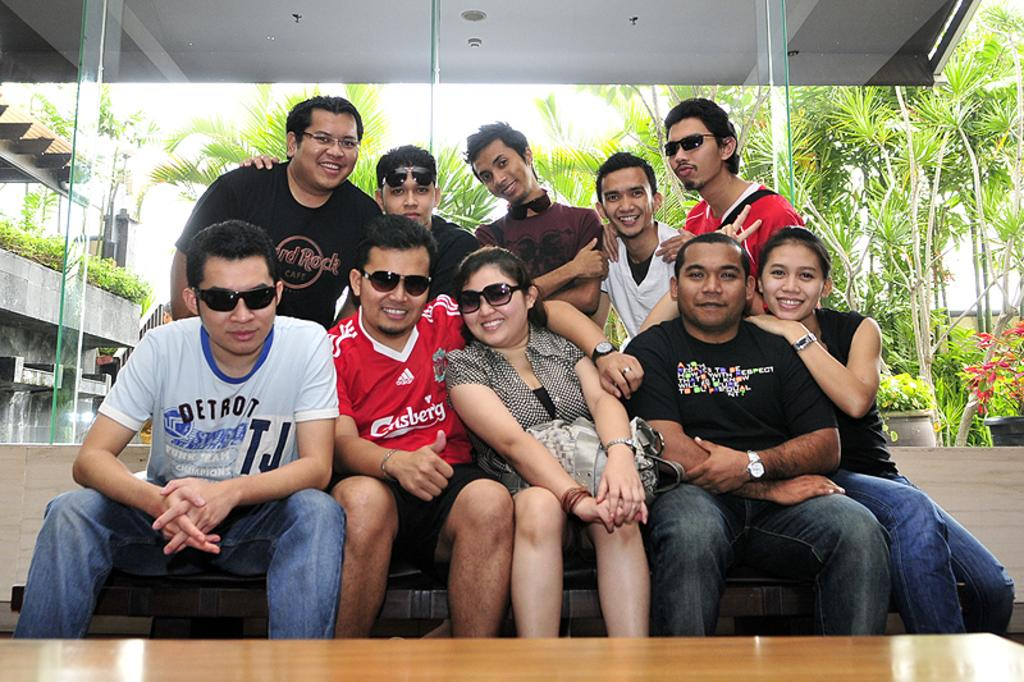What is happening in the foreground of the image? There are people sitting in front of a table in the foreground area of the image. What can be seen in the background of the image? Glass windows, greenery, a building, and the sky are visible in the background. What type of bead is being used to decorate the table in the image? There is no bead present in the image; the table is not decorated with any beads. What kind of club can be seen in the hands of the people in the image? There is no club visible in the image; the people are sitting at a table and not holding any clubs. 